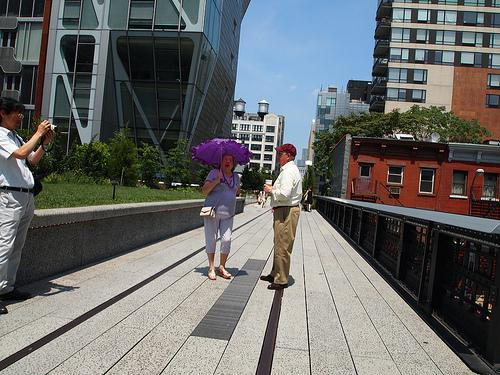Question: who is taking a picture?
Choices:
A. The grandma.
B. The man.
C. The mother.
D. The children.
Answer with the letter. Answer: B Question: why is the man holding a camera?
Choices:
A. To keep it from getting stolen.
B. To get out more film.
C. To find the case.
D. To take a picture.
Answer with the letter. Answer: D Question: what color is the umbrella?
Choices:
A. Red.
B. Orange.
C. Yellow.
D. Purple.
Answer with the letter. Answer: D Question: where are the people?
Choices:
A. In the countryside.
B. At the beach.
C. In a city.
D. In the mountains.
Answer with the letter. Answer: C 